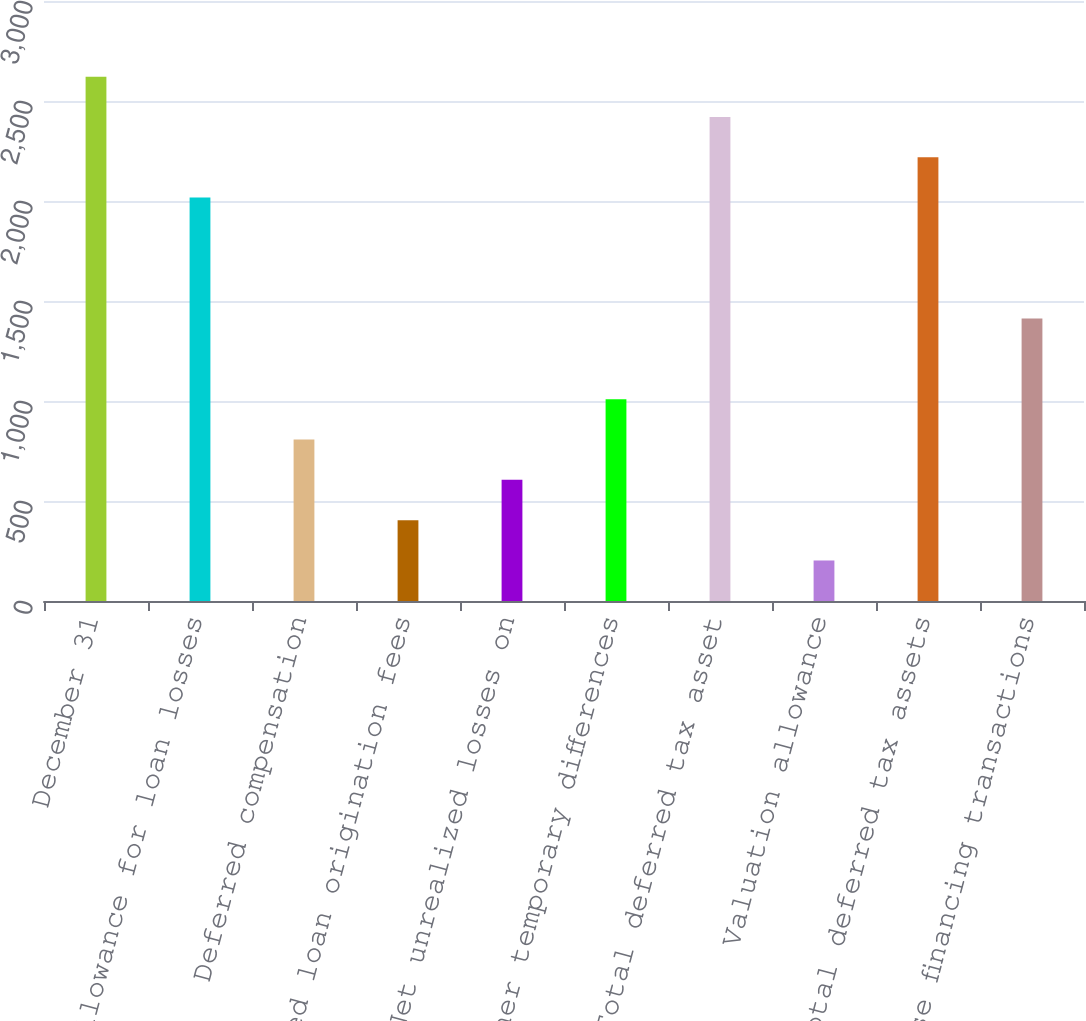Convert chart to OTSL. <chart><loc_0><loc_0><loc_500><loc_500><bar_chart><fcel>December 31<fcel>Allowance for loan losses<fcel>Deferred compensation<fcel>Deferred loan origination fees<fcel>Net unrealized losses on<fcel>Other temporary differences<fcel>Total deferred tax asset<fcel>Valuation allowance<fcel>Total deferred tax assets<fcel>Lease financing transactions<nl><fcel>2621.8<fcel>2017<fcel>807.4<fcel>404.2<fcel>605.8<fcel>1009<fcel>2420.2<fcel>202.6<fcel>2218.6<fcel>1412.2<nl></chart> 